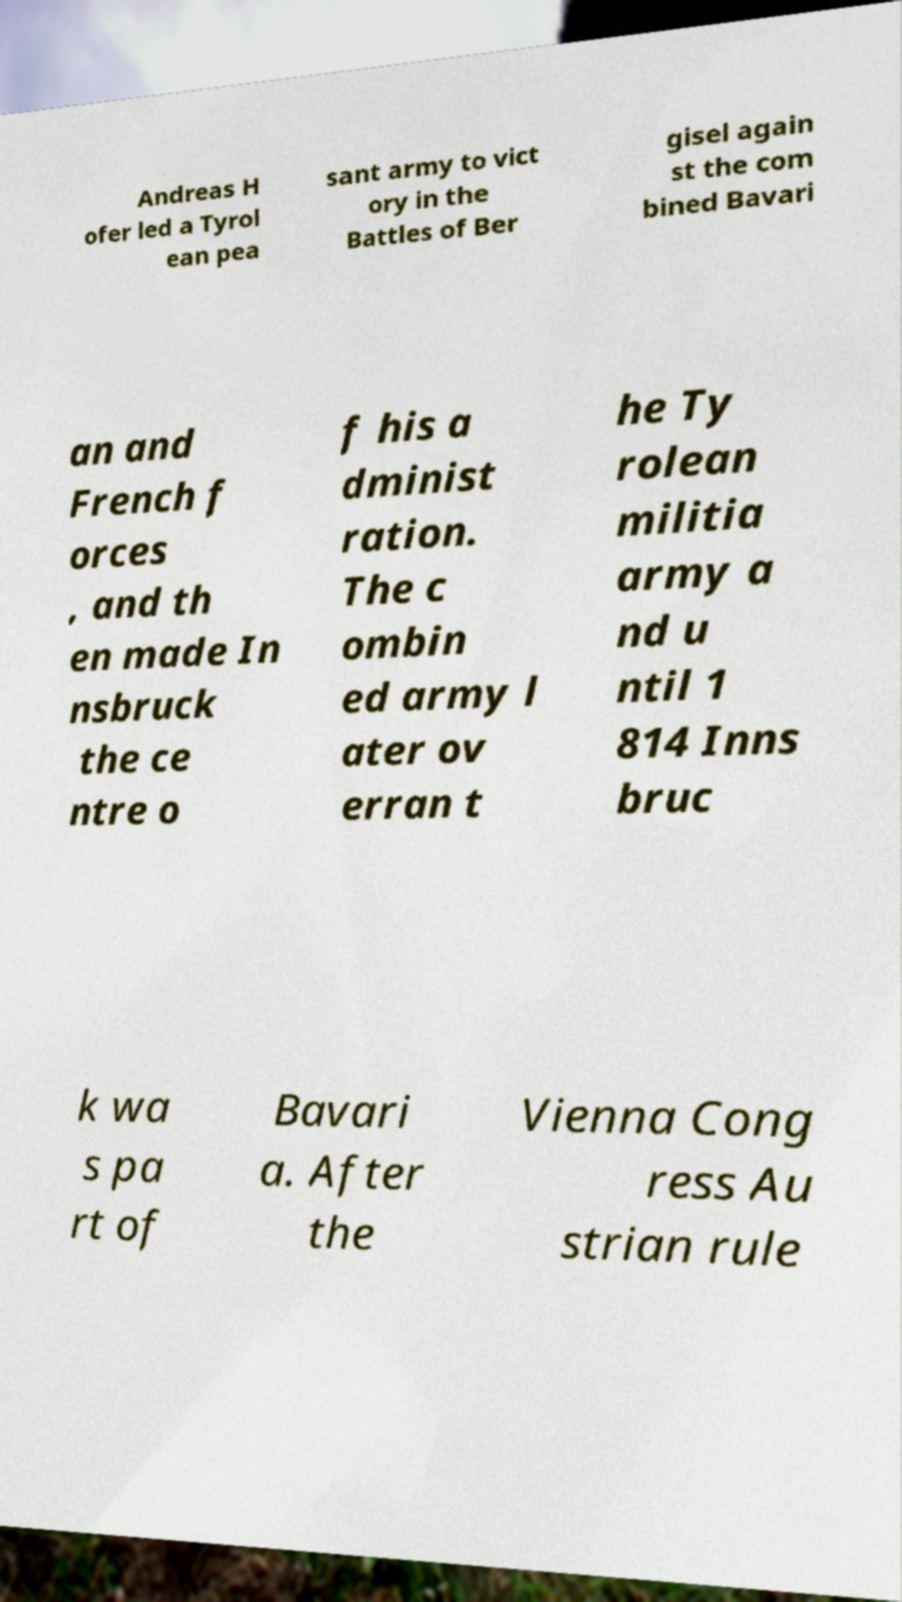Can you accurately transcribe the text from the provided image for me? Andreas H ofer led a Tyrol ean pea sant army to vict ory in the Battles of Ber gisel again st the com bined Bavari an and French f orces , and th en made In nsbruck the ce ntre o f his a dminist ration. The c ombin ed army l ater ov erran t he Ty rolean militia army a nd u ntil 1 814 Inns bruc k wa s pa rt of Bavari a. After the Vienna Cong ress Au strian rule 